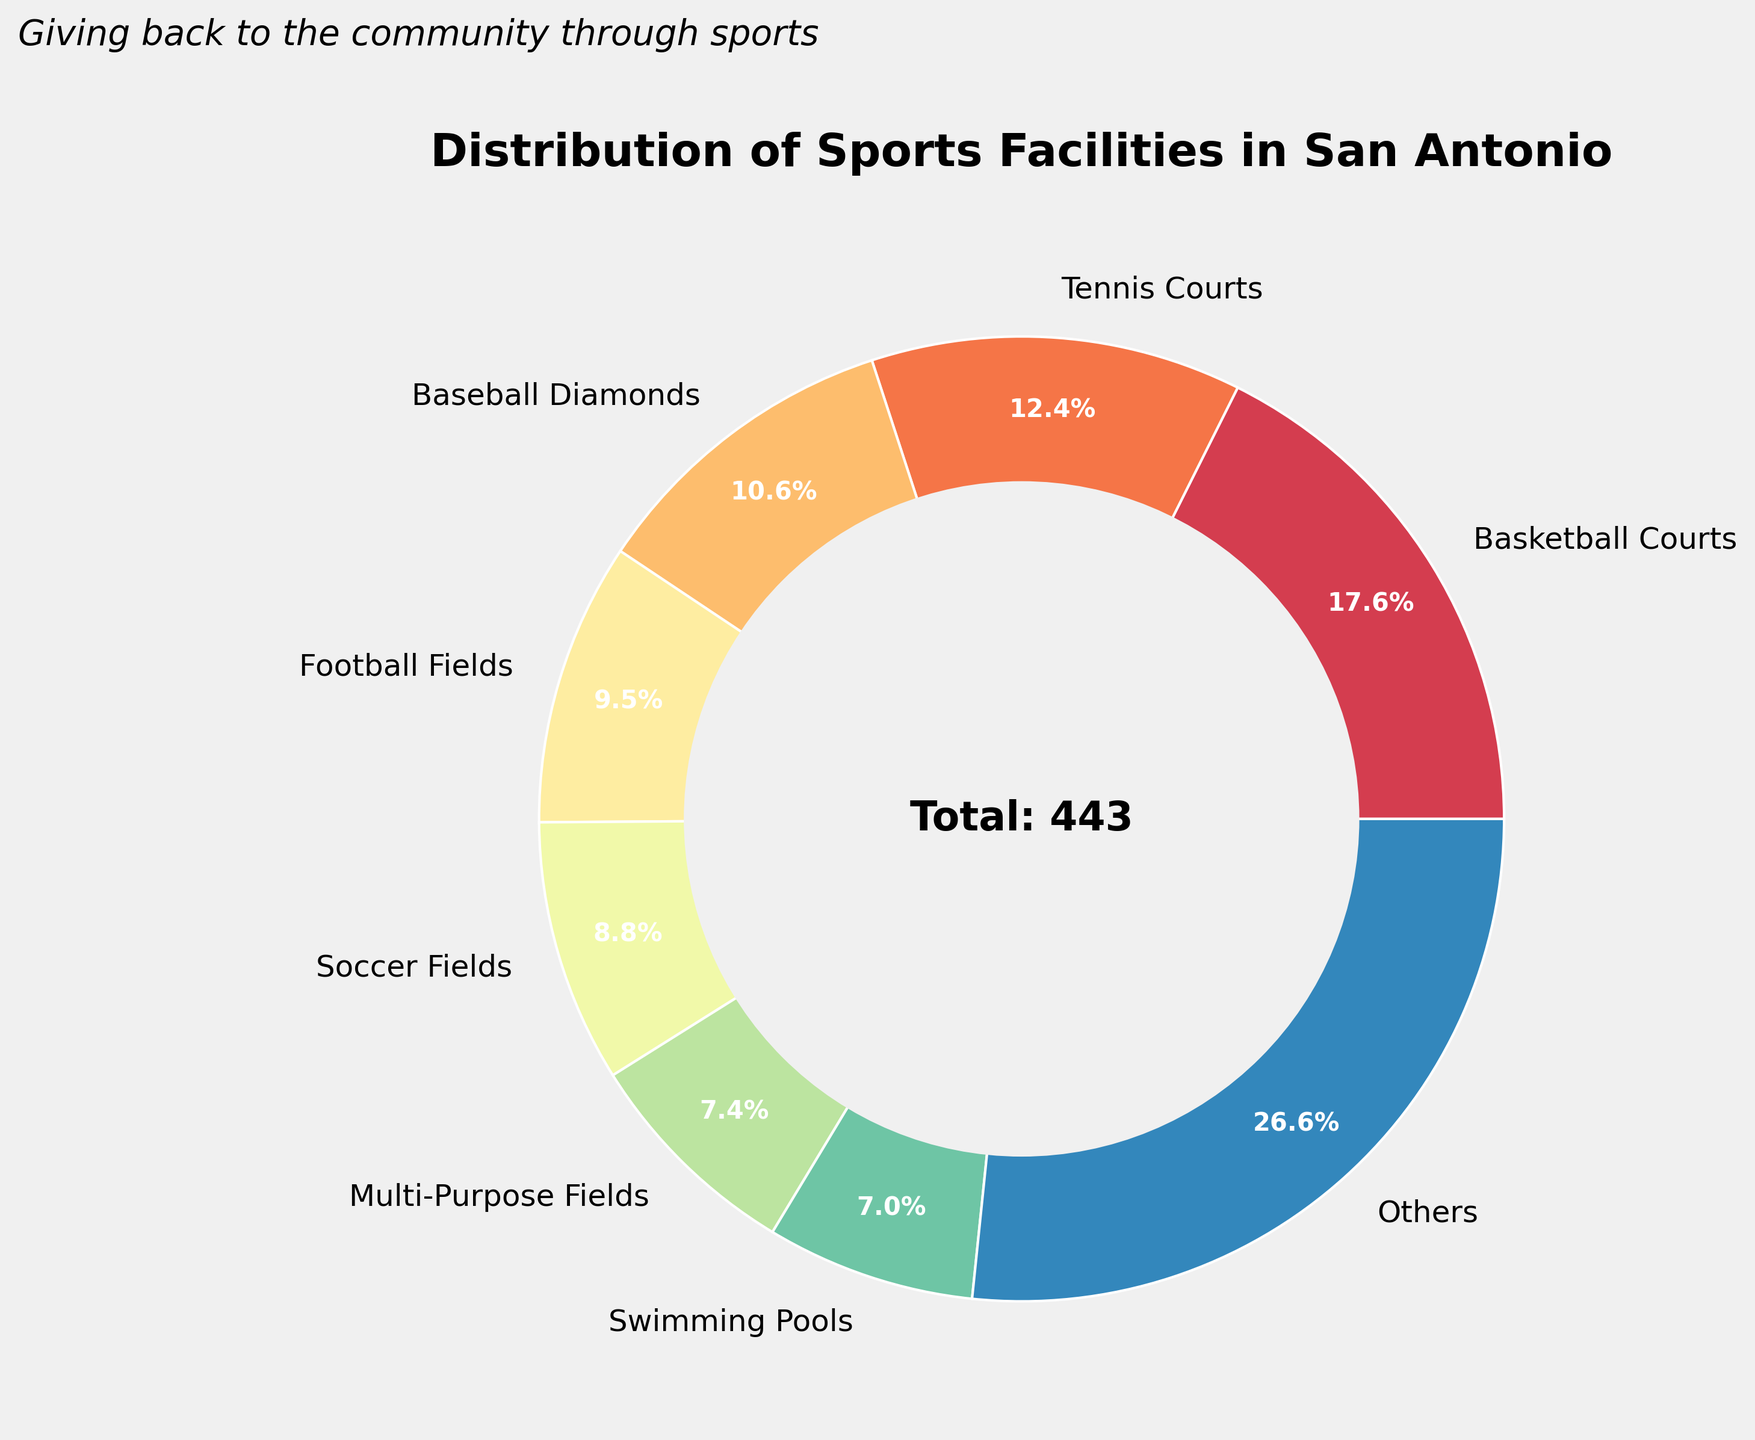What percentage of the sports facilities are basketball courts? Basketball courts account for 78 of the total 363 facilities. Calculate the percentage by dividing 78 by 363 and multiplying by 100: (78 / 363) * 100 ≈ 21.5%
Answer: 21.5% Which sports facility type has the lowest count? The pie chart shows that golf courses and disc golf courses are among the smallest slices. By reviewing the data, disc golf courts have the smallest count with 6.
Answer: Disc golf courses How many more basketball courts are there compared to swimming pools? The count of basketball courts is 78, and swimming pools is 31. Subtract the number of swimming pools from basketball courts: 78 - 31 = 47
Answer: 47 What is the total count of the top 3 sports facility types? The top 3 sports facility types by count are basketball courts (78), tennis courts (55), and baseball diamonds (47). Sum their counts: 78 + 55 + 47 = 180
Answer: 180 Are football fields and soccer fields combined more than the basketball courts alone? Add the counts of football fields (42) and soccer fields (39): 42 + 39 = 81, which is greater than the count of basketball courts (78).
Answer: Yes Which category occupies more space in the pie chart: tennis courts or baseball diamonds? The pie chart shows slices with varying sizes. The tennis courts slice is larger than the baseball diamonds slice, indicating a higher count.
Answer: Tennis courts What percentage of facilities are not part of the top 7 categories? From the data, the remaining categories below the top 7 sum up to "Others." Percentages of the first 7 categories are approximately: Basketball Courts: 21.5%, Tennis Courts: 15.2%, Baseball Diamonds: 12.9%, Multi-Purpose Fields: 9.1%, Swimming Pools: 8.5%, Football Fields: 11.6%, Soccer Fields: 10.7%. Summing them: 21.5% + 15.2% + 12.9% + 9.1% + 8.5% + 11.6% + 10.7% = 89.5%. Therefore, the "Others" category is 100% - 89.5% = 10.5%.
Answer: 10.5% What is the combined percentage of fitness zones and pickleball courts? Fitness zones (22) and pickleball courts (18) have respective percentages. Calculate each: (22 / 363) * 100 ≈ 6.1%, (18 / 363) * 100 ≈ 5%. The combined percentage is 6.1% + 5% = 11.1%.
Answer: 11.1% How many types of facilities have counts greater than 30 but less than 50? From the data, the types that fall in this range are: Football Fields (42), Swimming Pools (31), Soccer Fields (39), Baseball Diamonds (47). Count these types: 42, 31, 39, 47. There are 4 types.
Answer: 4 